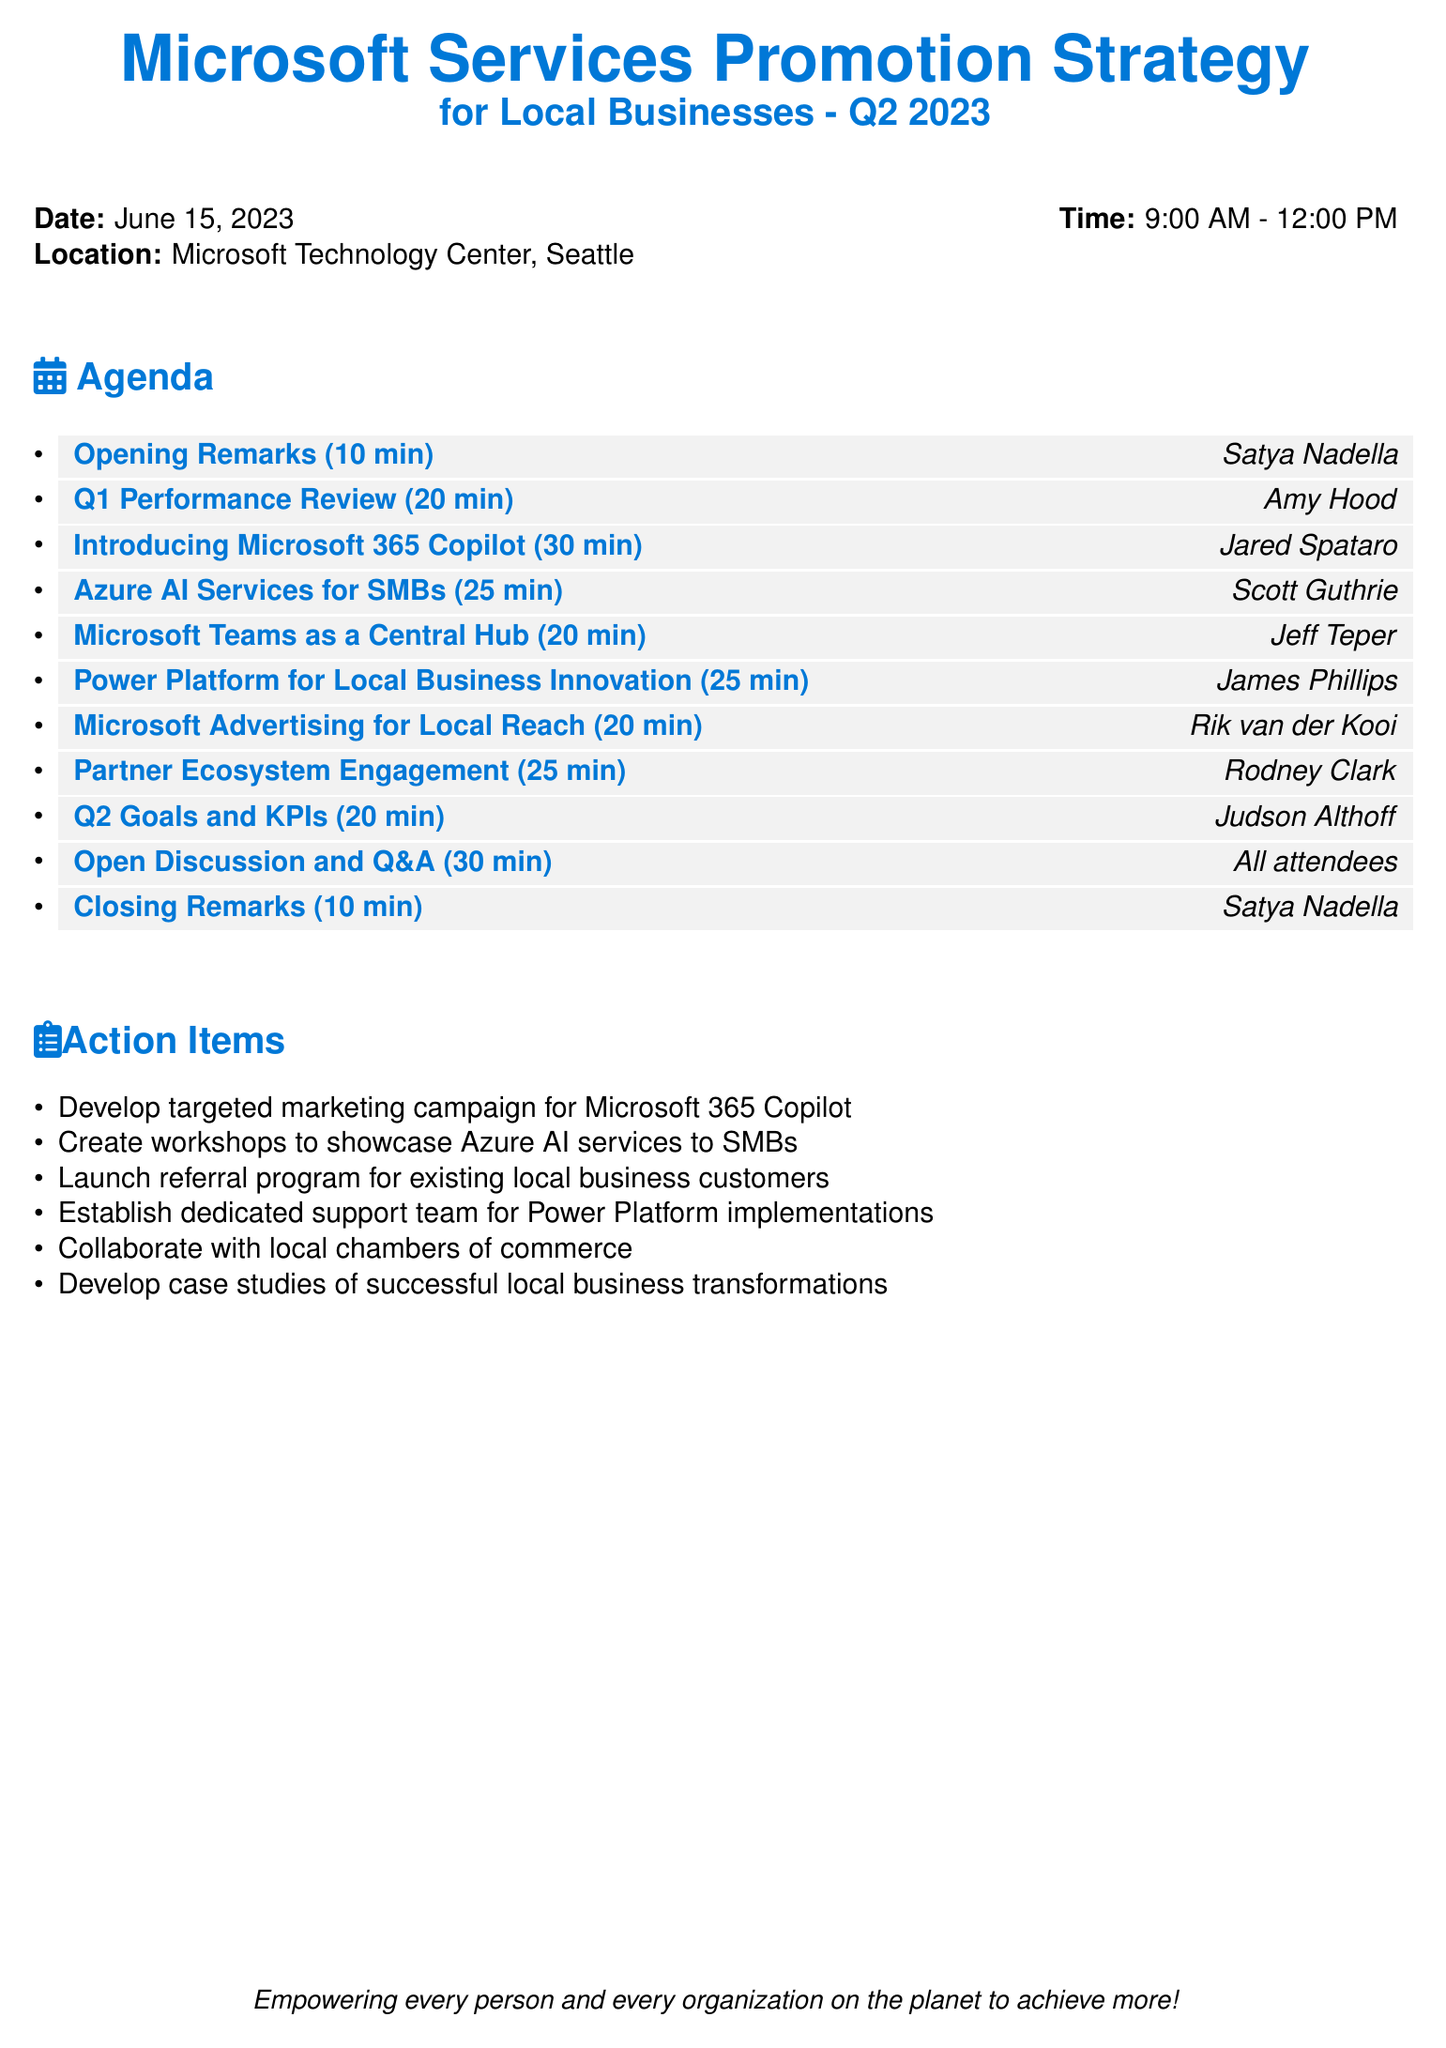What is the date of the meeting? The date of the meeting is specified at the beginning of the document.
Answer: June 15, 2023 Who is the speaker for the "Q1 Performance Review" section? Each agenda item lists a specific speaker responsible for that topic.
Answer: Amy Hood How long is the "Open Discussion and Q&A" session? The duration of each agenda item is detailed alongside its title.
Answer: 30 minutes What is the focus of the "Introducing Microsoft 365 Copilot" presentation? The description of each agenda item provides insight into its content and purpose.
Answer: Transform local business productivity How many action items are listed in the document? The action items section contains a list that counts the items.
Answer: Six Who will give the closing remarks? The speaker for the closing remarks is indicated in the agenda items.
Answer: Satya Nadella What is one proposed strategy for local businesses mentioned in the action items? Each action item defines a specific initiative aimed at local businesses.
Answer: Develop a targeted marketing campaign for Microsoft 365 Copilot Which Microsoft service is focused on in the "Power Platform for Local Business Innovation" session? Each topic title gives a clue about which Microsoft service is being discussed.
Answer: Power Platform 